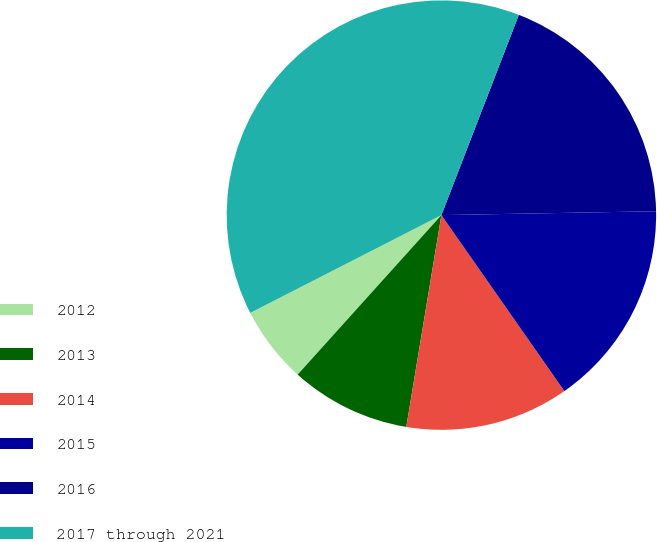Convert chart. <chart><loc_0><loc_0><loc_500><loc_500><pie_chart><fcel>2012<fcel>2013<fcel>2014<fcel>2015<fcel>2016<fcel>2017 through 2021<nl><fcel>5.8%<fcel>9.06%<fcel>12.32%<fcel>15.58%<fcel>18.84%<fcel>38.4%<nl></chart> 